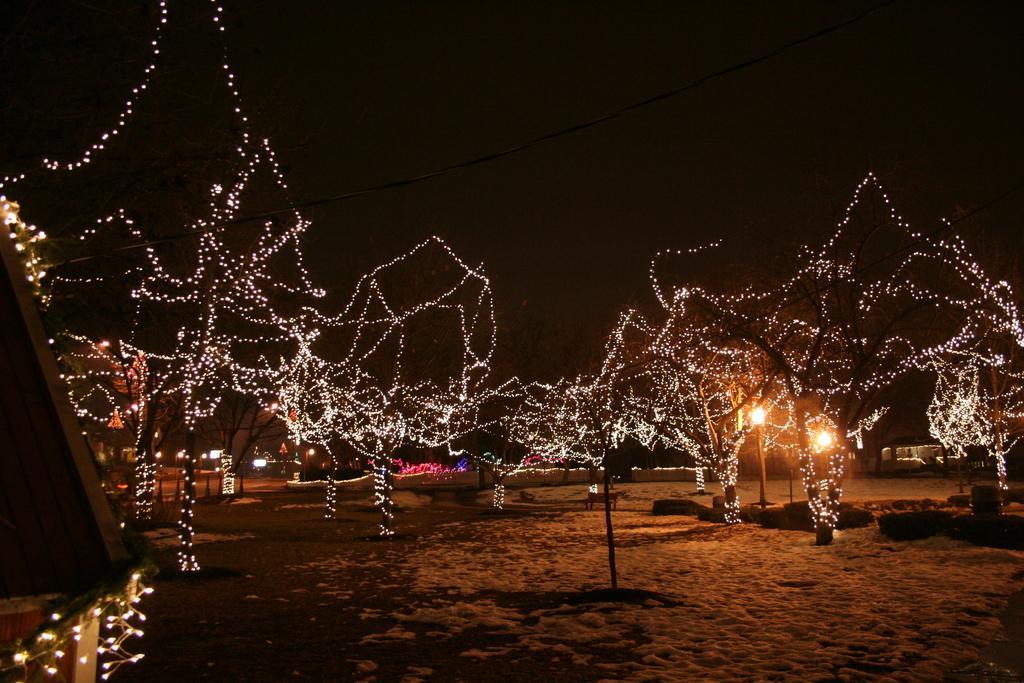Please provide a concise description of this image. In this image I can see few lights and they are decorated to the trees. Background the sky is in black color. 